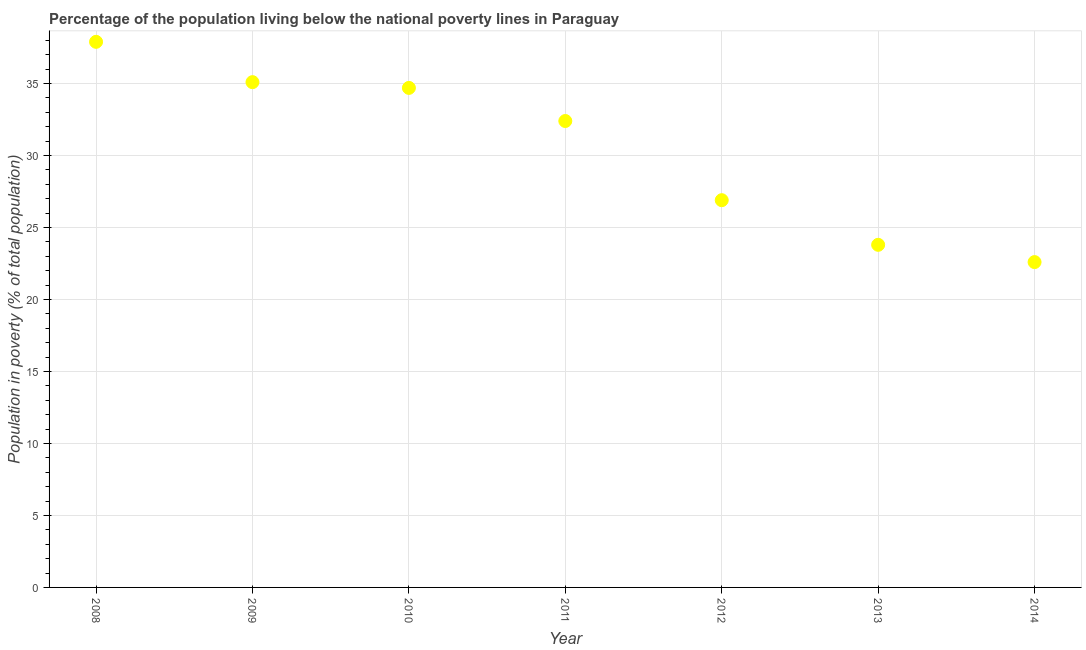What is the percentage of population living below poverty line in 2008?
Make the answer very short. 37.9. Across all years, what is the maximum percentage of population living below poverty line?
Offer a very short reply. 37.9. Across all years, what is the minimum percentage of population living below poverty line?
Keep it short and to the point. 22.6. In which year was the percentage of population living below poverty line maximum?
Make the answer very short. 2008. In which year was the percentage of population living below poverty line minimum?
Offer a very short reply. 2014. What is the sum of the percentage of population living below poverty line?
Your answer should be compact. 213.4. What is the average percentage of population living below poverty line per year?
Provide a succinct answer. 30.49. What is the median percentage of population living below poverty line?
Offer a terse response. 32.4. In how many years, is the percentage of population living below poverty line greater than 30 %?
Keep it short and to the point. 4. What is the ratio of the percentage of population living below poverty line in 2010 to that in 2013?
Your answer should be compact. 1.46. What is the difference between the highest and the second highest percentage of population living below poverty line?
Your response must be concise. 2.8. Is the sum of the percentage of population living below poverty line in 2011 and 2012 greater than the maximum percentage of population living below poverty line across all years?
Give a very brief answer. Yes. What is the difference between the highest and the lowest percentage of population living below poverty line?
Offer a very short reply. 15.3. In how many years, is the percentage of population living below poverty line greater than the average percentage of population living below poverty line taken over all years?
Your response must be concise. 4. How many dotlines are there?
Make the answer very short. 1. Does the graph contain any zero values?
Offer a very short reply. No. What is the title of the graph?
Offer a terse response. Percentage of the population living below the national poverty lines in Paraguay. What is the label or title of the X-axis?
Your answer should be compact. Year. What is the label or title of the Y-axis?
Offer a terse response. Population in poverty (% of total population). What is the Population in poverty (% of total population) in 2008?
Make the answer very short. 37.9. What is the Population in poverty (% of total population) in 2009?
Provide a short and direct response. 35.1. What is the Population in poverty (% of total population) in 2010?
Provide a succinct answer. 34.7. What is the Population in poverty (% of total population) in 2011?
Give a very brief answer. 32.4. What is the Population in poverty (% of total population) in 2012?
Ensure brevity in your answer.  26.9. What is the Population in poverty (% of total population) in 2013?
Keep it short and to the point. 23.8. What is the Population in poverty (% of total population) in 2014?
Your answer should be compact. 22.6. What is the difference between the Population in poverty (% of total population) in 2008 and 2012?
Provide a short and direct response. 11. What is the difference between the Population in poverty (% of total population) in 2009 and 2011?
Offer a terse response. 2.7. What is the difference between the Population in poverty (% of total population) in 2009 and 2013?
Ensure brevity in your answer.  11.3. What is the difference between the Population in poverty (% of total population) in 2010 and 2011?
Give a very brief answer. 2.3. What is the difference between the Population in poverty (% of total population) in 2010 and 2013?
Offer a very short reply. 10.9. What is the difference between the Population in poverty (% of total population) in 2012 and 2013?
Provide a succinct answer. 3.1. What is the difference between the Population in poverty (% of total population) in 2012 and 2014?
Ensure brevity in your answer.  4.3. What is the difference between the Population in poverty (% of total population) in 2013 and 2014?
Offer a very short reply. 1.2. What is the ratio of the Population in poverty (% of total population) in 2008 to that in 2010?
Offer a very short reply. 1.09. What is the ratio of the Population in poverty (% of total population) in 2008 to that in 2011?
Offer a very short reply. 1.17. What is the ratio of the Population in poverty (% of total population) in 2008 to that in 2012?
Provide a short and direct response. 1.41. What is the ratio of the Population in poverty (% of total population) in 2008 to that in 2013?
Ensure brevity in your answer.  1.59. What is the ratio of the Population in poverty (% of total population) in 2008 to that in 2014?
Give a very brief answer. 1.68. What is the ratio of the Population in poverty (% of total population) in 2009 to that in 2011?
Your answer should be compact. 1.08. What is the ratio of the Population in poverty (% of total population) in 2009 to that in 2012?
Offer a terse response. 1.3. What is the ratio of the Population in poverty (% of total population) in 2009 to that in 2013?
Keep it short and to the point. 1.48. What is the ratio of the Population in poverty (% of total population) in 2009 to that in 2014?
Offer a terse response. 1.55. What is the ratio of the Population in poverty (% of total population) in 2010 to that in 2011?
Your answer should be compact. 1.07. What is the ratio of the Population in poverty (% of total population) in 2010 to that in 2012?
Offer a terse response. 1.29. What is the ratio of the Population in poverty (% of total population) in 2010 to that in 2013?
Ensure brevity in your answer.  1.46. What is the ratio of the Population in poverty (% of total population) in 2010 to that in 2014?
Offer a very short reply. 1.53. What is the ratio of the Population in poverty (% of total population) in 2011 to that in 2012?
Give a very brief answer. 1.2. What is the ratio of the Population in poverty (% of total population) in 2011 to that in 2013?
Make the answer very short. 1.36. What is the ratio of the Population in poverty (% of total population) in 2011 to that in 2014?
Provide a succinct answer. 1.43. What is the ratio of the Population in poverty (% of total population) in 2012 to that in 2013?
Offer a very short reply. 1.13. What is the ratio of the Population in poverty (% of total population) in 2012 to that in 2014?
Keep it short and to the point. 1.19. What is the ratio of the Population in poverty (% of total population) in 2013 to that in 2014?
Ensure brevity in your answer.  1.05. 